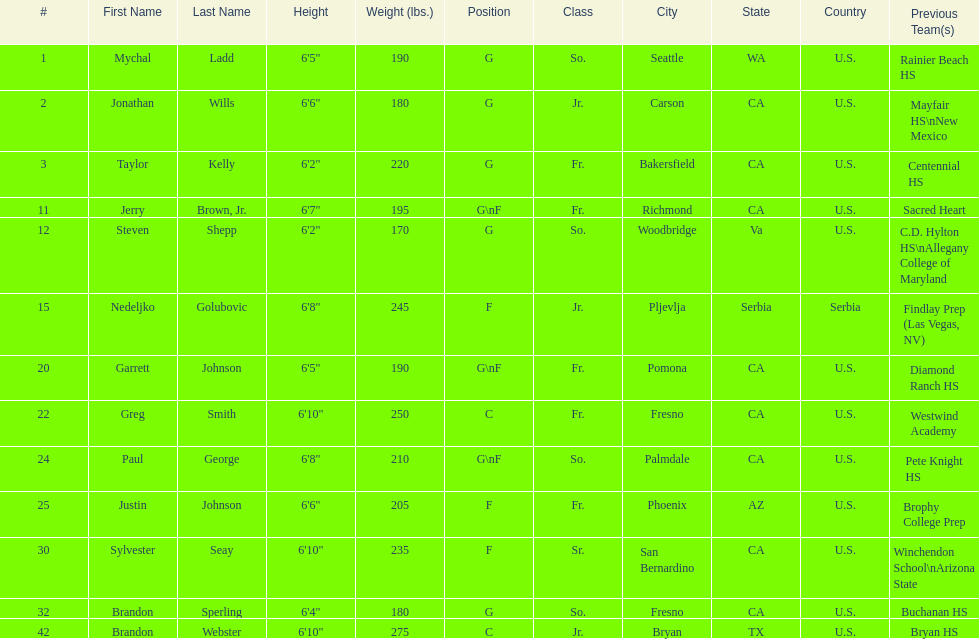Is the number of freshmen (fr.) greater than, equal to, or less than the number of juniors (jr.)? Greater. 